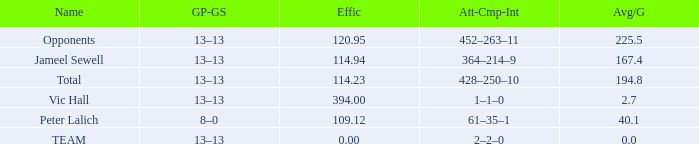Avg/G that has a GP-GS of 13–13, and a Effic smaller than 114.23 has what total of numbers? 1.0. 